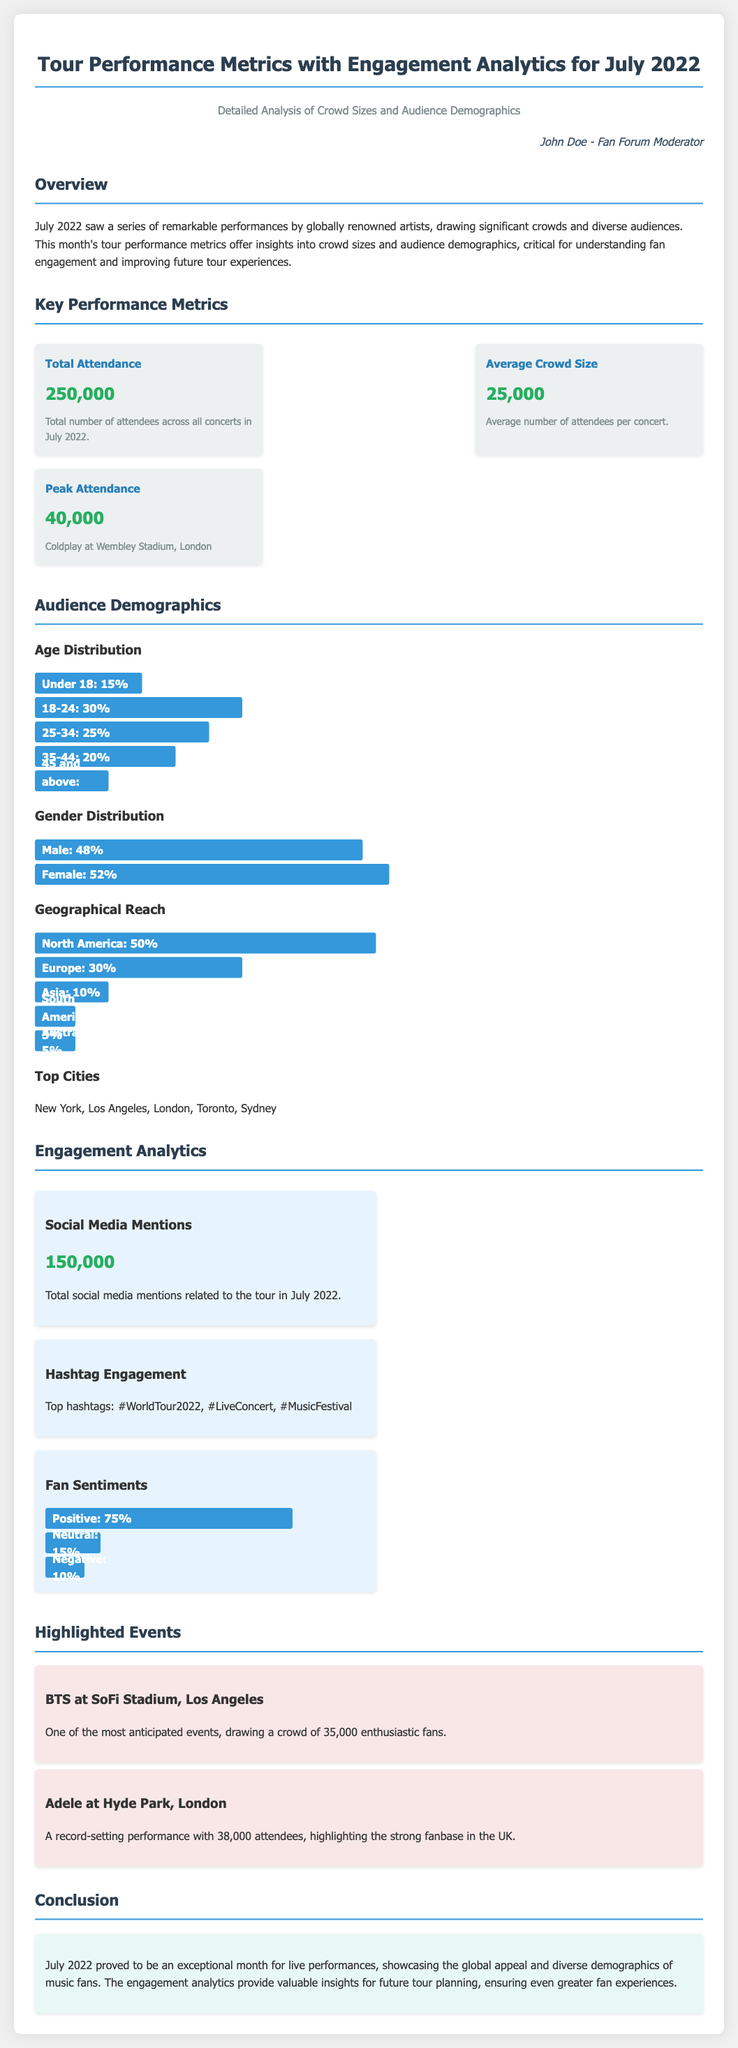What was the total attendance in July 2022? The total attendance is mentioned as 250,000, which represents the total number of attendees across all concerts in July 2022.
Answer: 250,000 What was the average crowd size per concert? The average crowd size, calculated from the total attendance, is stated as 25,000 attendees per concert.
Answer: 25,000 Which event had the peak attendance? The document specifies Coldplay at Wembley Stadium, London, as the event with the peak attendance.
Answer: Coldplay at Wembley Stadium, London What percentage of attendees were aged 18-24? The age distribution indicates that 30% of attendees fall within the 18-24 age range.
Answer: 30% How many social media mentions were recorded? The total number of social media mentions related to the tour in July 2022 is given as 150,000.
Answer: 150,000 What is the gender distribution of attendees? The attendance gender distribution shows that 48% were male and 52% were female, indicating a slight majority of female attendees.
Answer: 48% male, 52% female Which city had the highest attendance? Among the top cities mentioned for attendance, New York is included but not specifically labeled as the highest in the provided data.
Answer: New York What percentage of fan sentiments were positive? The document states that 75% of the sentiments expressed by fans were positive.
Answer: 75% Which performance attracted a crowd of 38,000? Adele at Hyde Park, London, is highlighted in the document as attracting a crowd of 38,000 attendees.
Answer: Adele at Hyde Park, London 